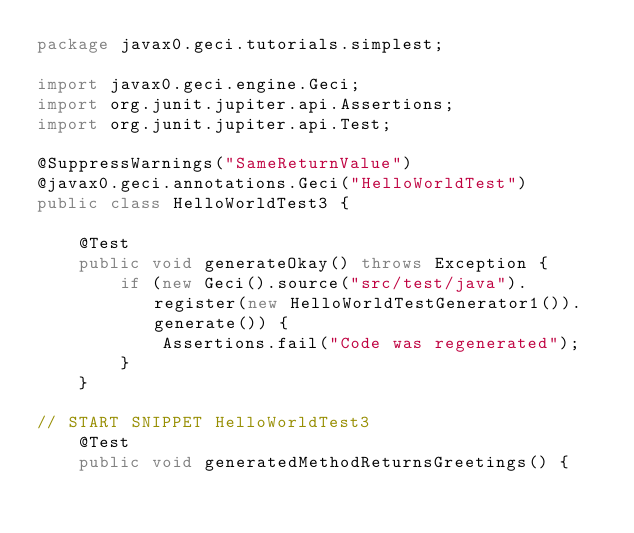Convert code to text. <code><loc_0><loc_0><loc_500><loc_500><_Java_>package javax0.geci.tutorials.simplest;

import javax0.geci.engine.Geci;
import org.junit.jupiter.api.Assertions;
import org.junit.jupiter.api.Test;

@SuppressWarnings("SameReturnValue")
@javax0.geci.annotations.Geci("HelloWorldTest")
public class HelloWorldTest3 {

    @Test
    public void generateOkay() throws Exception {
        if (new Geci().source("src/test/java").register(new HelloWorldTestGenerator1()).generate()) {
            Assertions.fail("Code was regenerated");
        }
    }

// START SNIPPET HelloWorldTest3
    @Test
    public void generatedMethodReturnsGreetings() {</code> 